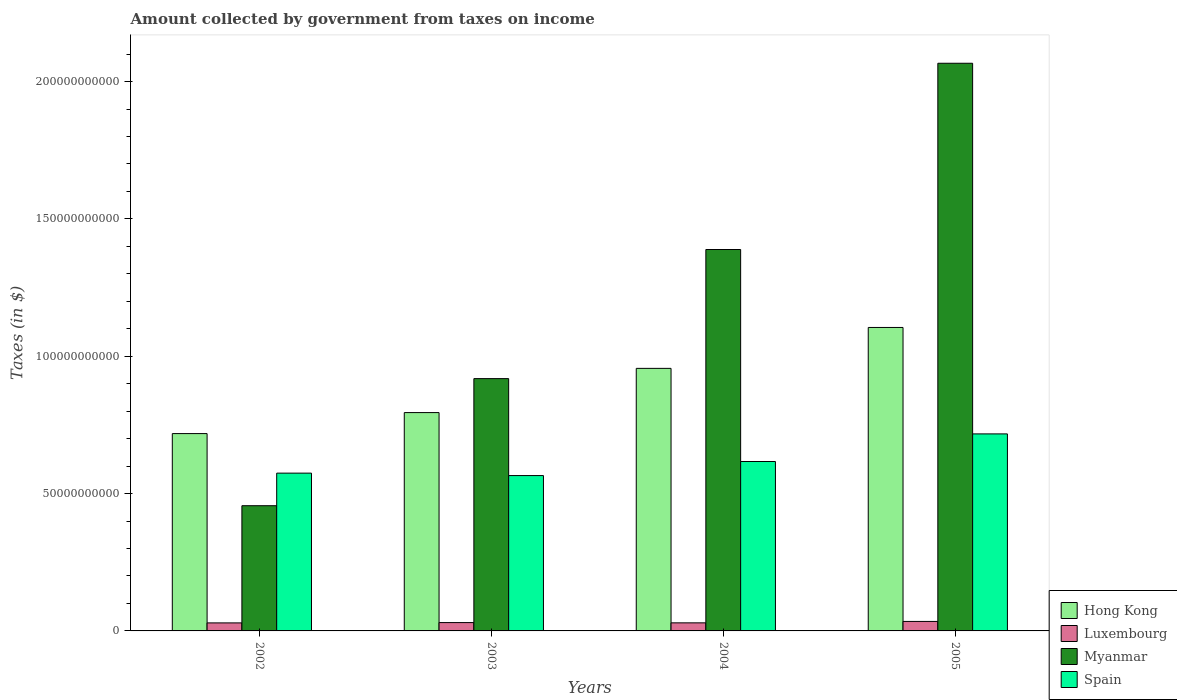How many different coloured bars are there?
Ensure brevity in your answer.  4. How many groups of bars are there?
Provide a short and direct response. 4. Are the number of bars per tick equal to the number of legend labels?
Keep it short and to the point. Yes. Are the number of bars on each tick of the X-axis equal?
Provide a succinct answer. Yes. How many bars are there on the 1st tick from the left?
Offer a very short reply. 4. How many bars are there on the 4th tick from the right?
Offer a very short reply. 4. What is the label of the 1st group of bars from the left?
Offer a very short reply. 2002. What is the amount collected by government from taxes on income in Spain in 2005?
Provide a short and direct response. 7.17e+1. Across all years, what is the maximum amount collected by government from taxes on income in Spain?
Make the answer very short. 7.17e+1. Across all years, what is the minimum amount collected by government from taxes on income in Luxembourg?
Keep it short and to the point. 2.92e+09. In which year was the amount collected by government from taxes on income in Spain maximum?
Offer a very short reply. 2005. In which year was the amount collected by government from taxes on income in Myanmar minimum?
Provide a succinct answer. 2002. What is the total amount collected by government from taxes on income in Myanmar in the graph?
Ensure brevity in your answer.  4.83e+11. What is the difference between the amount collected by government from taxes on income in Myanmar in 2002 and that in 2005?
Ensure brevity in your answer.  -1.61e+11. What is the difference between the amount collected by government from taxes on income in Spain in 2003 and the amount collected by government from taxes on income in Myanmar in 2004?
Ensure brevity in your answer.  -8.23e+1. What is the average amount collected by government from taxes on income in Luxembourg per year?
Your answer should be compact. 3.09e+09. In the year 2004, what is the difference between the amount collected by government from taxes on income in Spain and amount collected by government from taxes on income in Hong Kong?
Provide a short and direct response. -3.39e+1. What is the ratio of the amount collected by government from taxes on income in Spain in 2003 to that in 2004?
Offer a terse response. 0.92. Is the difference between the amount collected by government from taxes on income in Spain in 2002 and 2005 greater than the difference between the amount collected by government from taxes on income in Hong Kong in 2002 and 2005?
Your answer should be very brief. Yes. What is the difference between the highest and the second highest amount collected by government from taxes on income in Luxembourg?
Provide a succinct answer. 4.19e+08. What is the difference between the highest and the lowest amount collected by government from taxes on income in Spain?
Give a very brief answer. 1.52e+1. In how many years, is the amount collected by government from taxes on income in Spain greater than the average amount collected by government from taxes on income in Spain taken over all years?
Your response must be concise. 1. Is the sum of the amount collected by government from taxes on income in Spain in 2002 and 2004 greater than the maximum amount collected by government from taxes on income in Hong Kong across all years?
Your response must be concise. Yes. Is it the case that in every year, the sum of the amount collected by government from taxes on income in Hong Kong and amount collected by government from taxes on income in Spain is greater than the sum of amount collected by government from taxes on income in Myanmar and amount collected by government from taxes on income in Luxembourg?
Your answer should be compact. No. What does the 3rd bar from the left in 2005 represents?
Give a very brief answer. Myanmar. What does the 1st bar from the right in 2004 represents?
Give a very brief answer. Spain. Is it the case that in every year, the sum of the amount collected by government from taxes on income in Spain and amount collected by government from taxes on income in Myanmar is greater than the amount collected by government from taxes on income in Luxembourg?
Make the answer very short. Yes. Are all the bars in the graph horizontal?
Give a very brief answer. No. How many years are there in the graph?
Offer a terse response. 4. Does the graph contain any zero values?
Keep it short and to the point. No. Does the graph contain grids?
Offer a very short reply. No. Where does the legend appear in the graph?
Ensure brevity in your answer.  Bottom right. What is the title of the graph?
Offer a terse response. Amount collected by government from taxes on income. Does "Mauritius" appear as one of the legend labels in the graph?
Ensure brevity in your answer.  No. What is the label or title of the Y-axis?
Your response must be concise. Taxes (in $). What is the Taxes (in $) in Hong Kong in 2002?
Your answer should be very brief. 7.18e+1. What is the Taxes (in $) of Luxembourg in 2002?
Make the answer very short. 2.92e+09. What is the Taxes (in $) of Myanmar in 2002?
Your response must be concise. 4.56e+1. What is the Taxes (in $) of Spain in 2002?
Provide a succinct answer. 5.74e+1. What is the Taxes (in $) in Hong Kong in 2003?
Provide a short and direct response. 7.95e+1. What is the Taxes (in $) in Luxembourg in 2003?
Your answer should be very brief. 3.03e+09. What is the Taxes (in $) of Myanmar in 2003?
Ensure brevity in your answer.  9.19e+1. What is the Taxes (in $) of Spain in 2003?
Make the answer very short. 5.66e+1. What is the Taxes (in $) of Hong Kong in 2004?
Offer a terse response. 9.56e+1. What is the Taxes (in $) in Luxembourg in 2004?
Your response must be concise. 2.94e+09. What is the Taxes (in $) of Myanmar in 2004?
Your answer should be compact. 1.39e+11. What is the Taxes (in $) in Spain in 2004?
Provide a succinct answer. 6.17e+1. What is the Taxes (in $) in Hong Kong in 2005?
Keep it short and to the point. 1.10e+11. What is the Taxes (in $) in Luxembourg in 2005?
Your answer should be very brief. 3.45e+09. What is the Taxes (in $) of Myanmar in 2005?
Offer a terse response. 2.07e+11. What is the Taxes (in $) in Spain in 2005?
Make the answer very short. 7.17e+1. Across all years, what is the maximum Taxes (in $) in Hong Kong?
Ensure brevity in your answer.  1.10e+11. Across all years, what is the maximum Taxes (in $) in Luxembourg?
Your response must be concise. 3.45e+09. Across all years, what is the maximum Taxes (in $) in Myanmar?
Give a very brief answer. 2.07e+11. Across all years, what is the maximum Taxes (in $) in Spain?
Give a very brief answer. 7.17e+1. Across all years, what is the minimum Taxes (in $) in Hong Kong?
Offer a very short reply. 7.18e+1. Across all years, what is the minimum Taxes (in $) in Luxembourg?
Keep it short and to the point. 2.92e+09. Across all years, what is the minimum Taxes (in $) of Myanmar?
Offer a very short reply. 4.56e+1. Across all years, what is the minimum Taxes (in $) of Spain?
Give a very brief answer. 5.66e+1. What is the total Taxes (in $) of Hong Kong in the graph?
Your answer should be compact. 3.57e+11. What is the total Taxes (in $) of Luxembourg in the graph?
Your answer should be very brief. 1.23e+1. What is the total Taxes (in $) of Myanmar in the graph?
Offer a terse response. 4.83e+11. What is the total Taxes (in $) of Spain in the graph?
Your answer should be very brief. 2.47e+11. What is the difference between the Taxes (in $) in Hong Kong in 2002 and that in 2003?
Give a very brief answer. -7.64e+09. What is the difference between the Taxes (in $) of Luxembourg in 2002 and that in 2003?
Ensure brevity in your answer.  -1.15e+08. What is the difference between the Taxes (in $) of Myanmar in 2002 and that in 2003?
Give a very brief answer. -4.63e+1. What is the difference between the Taxes (in $) of Spain in 2002 and that in 2003?
Ensure brevity in your answer.  8.89e+08. What is the difference between the Taxes (in $) of Hong Kong in 2002 and that in 2004?
Offer a terse response. -2.37e+1. What is the difference between the Taxes (in $) of Luxembourg in 2002 and that in 2004?
Your response must be concise. -1.84e+07. What is the difference between the Taxes (in $) in Myanmar in 2002 and that in 2004?
Provide a succinct answer. -9.33e+1. What is the difference between the Taxes (in $) in Spain in 2002 and that in 2004?
Provide a succinct answer. -4.23e+09. What is the difference between the Taxes (in $) in Hong Kong in 2002 and that in 2005?
Provide a succinct answer. -3.86e+1. What is the difference between the Taxes (in $) of Luxembourg in 2002 and that in 2005?
Ensure brevity in your answer.  -5.35e+08. What is the difference between the Taxes (in $) in Myanmar in 2002 and that in 2005?
Offer a very short reply. -1.61e+11. What is the difference between the Taxes (in $) in Spain in 2002 and that in 2005?
Provide a short and direct response. -1.43e+1. What is the difference between the Taxes (in $) of Hong Kong in 2003 and that in 2004?
Your answer should be very brief. -1.61e+1. What is the difference between the Taxes (in $) of Luxembourg in 2003 and that in 2004?
Give a very brief answer. 9.69e+07. What is the difference between the Taxes (in $) of Myanmar in 2003 and that in 2004?
Make the answer very short. -4.70e+1. What is the difference between the Taxes (in $) in Spain in 2003 and that in 2004?
Your answer should be very brief. -5.12e+09. What is the difference between the Taxes (in $) of Hong Kong in 2003 and that in 2005?
Give a very brief answer. -3.10e+1. What is the difference between the Taxes (in $) in Luxembourg in 2003 and that in 2005?
Provide a succinct answer. -4.19e+08. What is the difference between the Taxes (in $) of Myanmar in 2003 and that in 2005?
Give a very brief answer. -1.15e+11. What is the difference between the Taxes (in $) of Spain in 2003 and that in 2005?
Offer a terse response. -1.52e+1. What is the difference between the Taxes (in $) in Hong Kong in 2004 and that in 2005?
Provide a succinct answer. -1.49e+1. What is the difference between the Taxes (in $) of Luxembourg in 2004 and that in 2005?
Your answer should be compact. -5.16e+08. What is the difference between the Taxes (in $) in Myanmar in 2004 and that in 2005?
Keep it short and to the point. -6.78e+1. What is the difference between the Taxes (in $) of Spain in 2004 and that in 2005?
Give a very brief answer. -1.01e+1. What is the difference between the Taxes (in $) of Hong Kong in 2002 and the Taxes (in $) of Luxembourg in 2003?
Keep it short and to the point. 6.88e+1. What is the difference between the Taxes (in $) of Hong Kong in 2002 and the Taxes (in $) of Myanmar in 2003?
Provide a succinct answer. -2.00e+1. What is the difference between the Taxes (in $) in Hong Kong in 2002 and the Taxes (in $) in Spain in 2003?
Ensure brevity in your answer.  1.53e+1. What is the difference between the Taxes (in $) in Luxembourg in 2002 and the Taxes (in $) in Myanmar in 2003?
Offer a terse response. -8.89e+1. What is the difference between the Taxes (in $) in Luxembourg in 2002 and the Taxes (in $) in Spain in 2003?
Ensure brevity in your answer.  -5.36e+1. What is the difference between the Taxes (in $) in Myanmar in 2002 and the Taxes (in $) in Spain in 2003?
Provide a short and direct response. -1.10e+1. What is the difference between the Taxes (in $) in Hong Kong in 2002 and the Taxes (in $) in Luxembourg in 2004?
Keep it short and to the point. 6.89e+1. What is the difference between the Taxes (in $) of Hong Kong in 2002 and the Taxes (in $) of Myanmar in 2004?
Your response must be concise. -6.70e+1. What is the difference between the Taxes (in $) of Hong Kong in 2002 and the Taxes (in $) of Spain in 2004?
Your answer should be very brief. 1.02e+1. What is the difference between the Taxes (in $) in Luxembourg in 2002 and the Taxes (in $) in Myanmar in 2004?
Make the answer very short. -1.36e+11. What is the difference between the Taxes (in $) of Luxembourg in 2002 and the Taxes (in $) of Spain in 2004?
Offer a terse response. -5.88e+1. What is the difference between the Taxes (in $) of Myanmar in 2002 and the Taxes (in $) of Spain in 2004?
Keep it short and to the point. -1.61e+1. What is the difference between the Taxes (in $) of Hong Kong in 2002 and the Taxes (in $) of Luxembourg in 2005?
Your response must be concise. 6.84e+1. What is the difference between the Taxes (in $) in Hong Kong in 2002 and the Taxes (in $) in Myanmar in 2005?
Make the answer very short. -1.35e+11. What is the difference between the Taxes (in $) in Hong Kong in 2002 and the Taxes (in $) in Spain in 2005?
Your answer should be compact. 1.16e+08. What is the difference between the Taxes (in $) of Luxembourg in 2002 and the Taxes (in $) of Myanmar in 2005?
Provide a short and direct response. -2.04e+11. What is the difference between the Taxes (in $) in Luxembourg in 2002 and the Taxes (in $) in Spain in 2005?
Your answer should be very brief. -6.88e+1. What is the difference between the Taxes (in $) of Myanmar in 2002 and the Taxes (in $) of Spain in 2005?
Make the answer very short. -2.61e+1. What is the difference between the Taxes (in $) in Hong Kong in 2003 and the Taxes (in $) in Luxembourg in 2004?
Your response must be concise. 7.66e+1. What is the difference between the Taxes (in $) of Hong Kong in 2003 and the Taxes (in $) of Myanmar in 2004?
Offer a terse response. -5.94e+1. What is the difference between the Taxes (in $) of Hong Kong in 2003 and the Taxes (in $) of Spain in 2004?
Provide a succinct answer. 1.78e+1. What is the difference between the Taxes (in $) in Luxembourg in 2003 and the Taxes (in $) in Myanmar in 2004?
Provide a succinct answer. -1.36e+11. What is the difference between the Taxes (in $) of Luxembourg in 2003 and the Taxes (in $) of Spain in 2004?
Provide a short and direct response. -5.86e+1. What is the difference between the Taxes (in $) of Myanmar in 2003 and the Taxes (in $) of Spain in 2004?
Your response must be concise. 3.02e+1. What is the difference between the Taxes (in $) in Hong Kong in 2003 and the Taxes (in $) in Luxembourg in 2005?
Keep it short and to the point. 7.60e+1. What is the difference between the Taxes (in $) of Hong Kong in 2003 and the Taxes (in $) of Myanmar in 2005?
Your response must be concise. -1.27e+11. What is the difference between the Taxes (in $) of Hong Kong in 2003 and the Taxes (in $) of Spain in 2005?
Provide a succinct answer. 7.76e+09. What is the difference between the Taxes (in $) of Luxembourg in 2003 and the Taxes (in $) of Myanmar in 2005?
Give a very brief answer. -2.04e+11. What is the difference between the Taxes (in $) in Luxembourg in 2003 and the Taxes (in $) in Spain in 2005?
Your answer should be compact. -6.87e+1. What is the difference between the Taxes (in $) of Myanmar in 2003 and the Taxes (in $) of Spain in 2005?
Keep it short and to the point. 2.01e+1. What is the difference between the Taxes (in $) of Hong Kong in 2004 and the Taxes (in $) of Luxembourg in 2005?
Keep it short and to the point. 9.21e+1. What is the difference between the Taxes (in $) of Hong Kong in 2004 and the Taxes (in $) of Myanmar in 2005?
Keep it short and to the point. -1.11e+11. What is the difference between the Taxes (in $) in Hong Kong in 2004 and the Taxes (in $) in Spain in 2005?
Your response must be concise. 2.39e+1. What is the difference between the Taxes (in $) of Luxembourg in 2004 and the Taxes (in $) of Myanmar in 2005?
Your answer should be very brief. -2.04e+11. What is the difference between the Taxes (in $) of Luxembourg in 2004 and the Taxes (in $) of Spain in 2005?
Give a very brief answer. -6.88e+1. What is the difference between the Taxes (in $) of Myanmar in 2004 and the Taxes (in $) of Spain in 2005?
Your answer should be very brief. 6.71e+1. What is the average Taxes (in $) of Hong Kong per year?
Give a very brief answer. 8.94e+1. What is the average Taxes (in $) in Luxembourg per year?
Provide a succinct answer. 3.09e+09. What is the average Taxes (in $) in Myanmar per year?
Make the answer very short. 1.21e+11. What is the average Taxes (in $) of Spain per year?
Your answer should be very brief. 6.19e+1. In the year 2002, what is the difference between the Taxes (in $) in Hong Kong and Taxes (in $) in Luxembourg?
Offer a very short reply. 6.89e+1. In the year 2002, what is the difference between the Taxes (in $) in Hong Kong and Taxes (in $) in Myanmar?
Keep it short and to the point. 2.63e+1. In the year 2002, what is the difference between the Taxes (in $) in Hong Kong and Taxes (in $) in Spain?
Your answer should be very brief. 1.44e+1. In the year 2002, what is the difference between the Taxes (in $) in Luxembourg and Taxes (in $) in Myanmar?
Ensure brevity in your answer.  -4.27e+1. In the year 2002, what is the difference between the Taxes (in $) of Luxembourg and Taxes (in $) of Spain?
Provide a short and direct response. -5.45e+1. In the year 2002, what is the difference between the Taxes (in $) in Myanmar and Taxes (in $) in Spain?
Offer a terse response. -1.19e+1. In the year 2003, what is the difference between the Taxes (in $) in Hong Kong and Taxes (in $) in Luxembourg?
Provide a succinct answer. 7.65e+1. In the year 2003, what is the difference between the Taxes (in $) of Hong Kong and Taxes (in $) of Myanmar?
Offer a very short reply. -1.24e+1. In the year 2003, what is the difference between the Taxes (in $) of Hong Kong and Taxes (in $) of Spain?
Your answer should be compact. 2.29e+1. In the year 2003, what is the difference between the Taxes (in $) in Luxembourg and Taxes (in $) in Myanmar?
Provide a succinct answer. -8.88e+1. In the year 2003, what is the difference between the Taxes (in $) in Luxembourg and Taxes (in $) in Spain?
Your answer should be compact. -5.35e+1. In the year 2003, what is the difference between the Taxes (in $) of Myanmar and Taxes (in $) of Spain?
Your response must be concise. 3.53e+1. In the year 2004, what is the difference between the Taxes (in $) of Hong Kong and Taxes (in $) of Luxembourg?
Ensure brevity in your answer.  9.27e+1. In the year 2004, what is the difference between the Taxes (in $) in Hong Kong and Taxes (in $) in Myanmar?
Provide a short and direct response. -4.33e+1. In the year 2004, what is the difference between the Taxes (in $) of Hong Kong and Taxes (in $) of Spain?
Provide a short and direct response. 3.39e+1. In the year 2004, what is the difference between the Taxes (in $) of Luxembourg and Taxes (in $) of Myanmar?
Ensure brevity in your answer.  -1.36e+11. In the year 2004, what is the difference between the Taxes (in $) of Luxembourg and Taxes (in $) of Spain?
Offer a very short reply. -5.87e+1. In the year 2004, what is the difference between the Taxes (in $) in Myanmar and Taxes (in $) in Spain?
Provide a succinct answer. 7.72e+1. In the year 2005, what is the difference between the Taxes (in $) in Hong Kong and Taxes (in $) in Luxembourg?
Provide a succinct answer. 1.07e+11. In the year 2005, what is the difference between the Taxes (in $) in Hong Kong and Taxes (in $) in Myanmar?
Your response must be concise. -9.62e+1. In the year 2005, what is the difference between the Taxes (in $) in Hong Kong and Taxes (in $) in Spain?
Keep it short and to the point. 3.88e+1. In the year 2005, what is the difference between the Taxes (in $) in Luxembourg and Taxes (in $) in Myanmar?
Keep it short and to the point. -2.03e+11. In the year 2005, what is the difference between the Taxes (in $) in Luxembourg and Taxes (in $) in Spain?
Your answer should be very brief. -6.83e+1. In the year 2005, what is the difference between the Taxes (in $) in Myanmar and Taxes (in $) in Spain?
Give a very brief answer. 1.35e+11. What is the ratio of the Taxes (in $) of Hong Kong in 2002 to that in 2003?
Keep it short and to the point. 0.9. What is the ratio of the Taxes (in $) in Myanmar in 2002 to that in 2003?
Offer a very short reply. 0.5. What is the ratio of the Taxes (in $) in Spain in 2002 to that in 2003?
Offer a very short reply. 1.02. What is the ratio of the Taxes (in $) in Hong Kong in 2002 to that in 2004?
Provide a succinct answer. 0.75. What is the ratio of the Taxes (in $) in Myanmar in 2002 to that in 2004?
Provide a succinct answer. 0.33. What is the ratio of the Taxes (in $) of Spain in 2002 to that in 2004?
Give a very brief answer. 0.93. What is the ratio of the Taxes (in $) in Hong Kong in 2002 to that in 2005?
Make the answer very short. 0.65. What is the ratio of the Taxes (in $) of Luxembourg in 2002 to that in 2005?
Make the answer very short. 0.85. What is the ratio of the Taxes (in $) of Myanmar in 2002 to that in 2005?
Give a very brief answer. 0.22. What is the ratio of the Taxes (in $) in Spain in 2002 to that in 2005?
Provide a succinct answer. 0.8. What is the ratio of the Taxes (in $) of Hong Kong in 2003 to that in 2004?
Provide a succinct answer. 0.83. What is the ratio of the Taxes (in $) of Luxembourg in 2003 to that in 2004?
Your response must be concise. 1.03. What is the ratio of the Taxes (in $) in Myanmar in 2003 to that in 2004?
Your answer should be compact. 0.66. What is the ratio of the Taxes (in $) in Spain in 2003 to that in 2004?
Keep it short and to the point. 0.92. What is the ratio of the Taxes (in $) in Hong Kong in 2003 to that in 2005?
Your answer should be compact. 0.72. What is the ratio of the Taxes (in $) in Luxembourg in 2003 to that in 2005?
Offer a terse response. 0.88. What is the ratio of the Taxes (in $) of Myanmar in 2003 to that in 2005?
Ensure brevity in your answer.  0.44. What is the ratio of the Taxes (in $) in Spain in 2003 to that in 2005?
Provide a short and direct response. 0.79. What is the ratio of the Taxes (in $) in Hong Kong in 2004 to that in 2005?
Offer a very short reply. 0.87. What is the ratio of the Taxes (in $) in Luxembourg in 2004 to that in 2005?
Your response must be concise. 0.85. What is the ratio of the Taxes (in $) of Myanmar in 2004 to that in 2005?
Provide a succinct answer. 0.67. What is the ratio of the Taxes (in $) in Spain in 2004 to that in 2005?
Provide a succinct answer. 0.86. What is the difference between the highest and the second highest Taxes (in $) of Hong Kong?
Your answer should be compact. 1.49e+1. What is the difference between the highest and the second highest Taxes (in $) of Luxembourg?
Make the answer very short. 4.19e+08. What is the difference between the highest and the second highest Taxes (in $) in Myanmar?
Provide a succinct answer. 6.78e+1. What is the difference between the highest and the second highest Taxes (in $) of Spain?
Provide a short and direct response. 1.01e+1. What is the difference between the highest and the lowest Taxes (in $) of Hong Kong?
Provide a short and direct response. 3.86e+1. What is the difference between the highest and the lowest Taxes (in $) of Luxembourg?
Give a very brief answer. 5.35e+08. What is the difference between the highest and the lowest Taxes (in $) of Myanmar?
Your answer should be very brief. 1.61e+11. What is the difference between the highest and the lowest Taxes (in $) in Spain?
Your answer should be compact. 1.52e+1. 